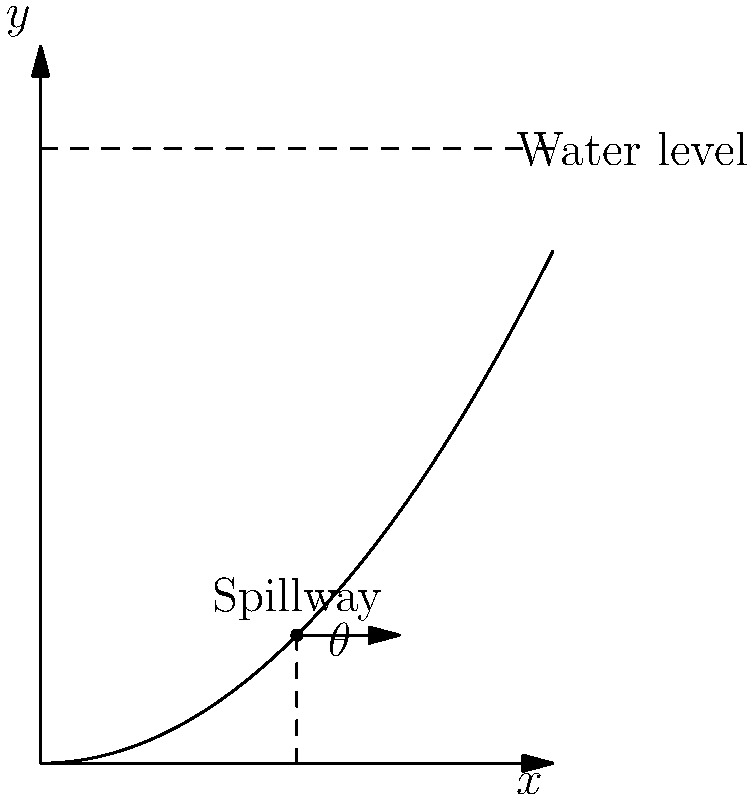As a bass guitarist, you're working on a project to create a musical piece inspired by the flow of water over a dam. To accurately represent the sound, you need to understand the optimal angle for the dam's spillway. Given the cross-sectional view of the dam where the spillway curve is represented by the function $y = 0.2x^2$, and the water level is at $y = 6$ units, at what angle $\theta$ (in degrees) should the spillway be constructed for optimal water flow? To find the optimal angle for the spillway, we'll follow these steps:

1. The spillway curve is given by $y = 0.2x^2$.

2. To find the angle $\theta$, we need to calculate the slope of the tangent line at the point where the water meets the spillway.

3. First, let's find the x-coordinate of this point by solving:
   $6 = 0.2x^2$
   $x^2 = 30$
   $x = \sqrt{30} \approx 5.477$

4. The slope of the tangent line at any point on the curve is given by the derivative of the function:
   $\frac{dy}{dx} = 0.4x$

5. At $x = \sqrt{30}$, the slope is:
   $\frac{dy}{dx} = 0.4\sqrt{30} \approx 2.191$

6. The angle $\theta$ is the arctangent of this slope:
   $\theta = \arctan(2.191)$

7. Convert to degrees:
   $\theta \approx 65.47°$

Therefore, the optimal angle for the spillway is approximately 65.47°.
Answer: 65.47° 